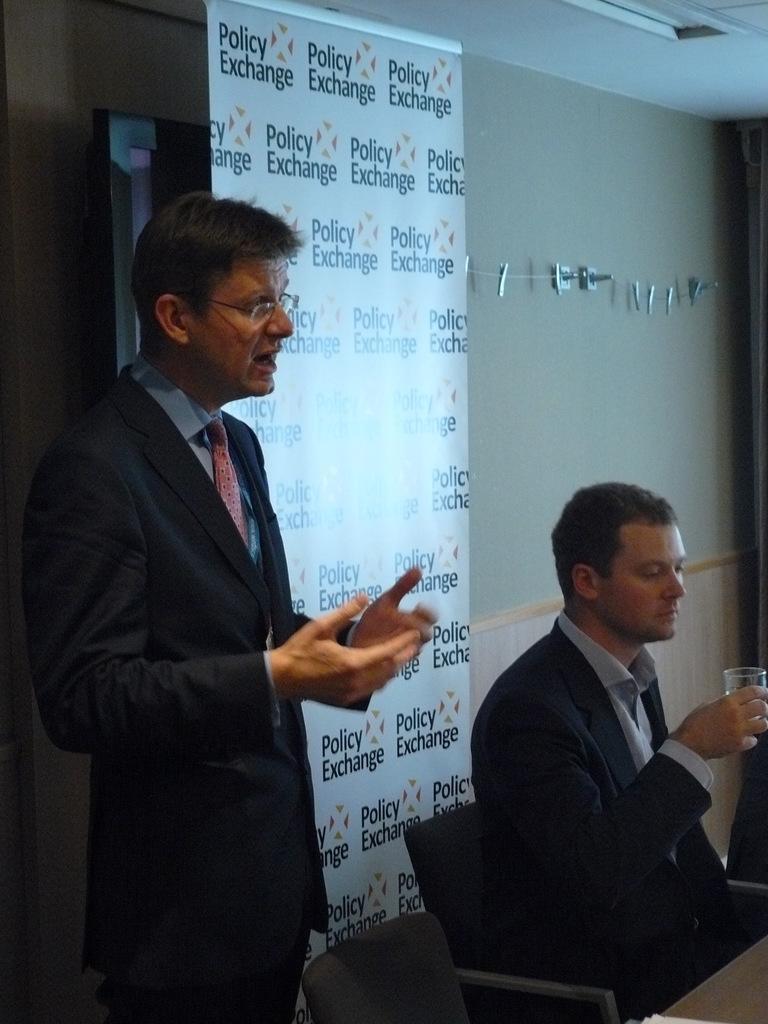Describe this image in one or two sentences. In this image, at the left side there is a man standing, at the right side there is a man sitting on the chair and he is holding a glass, at the background there is a poster, on that poster there is policy exchange is written, there is a wall. 